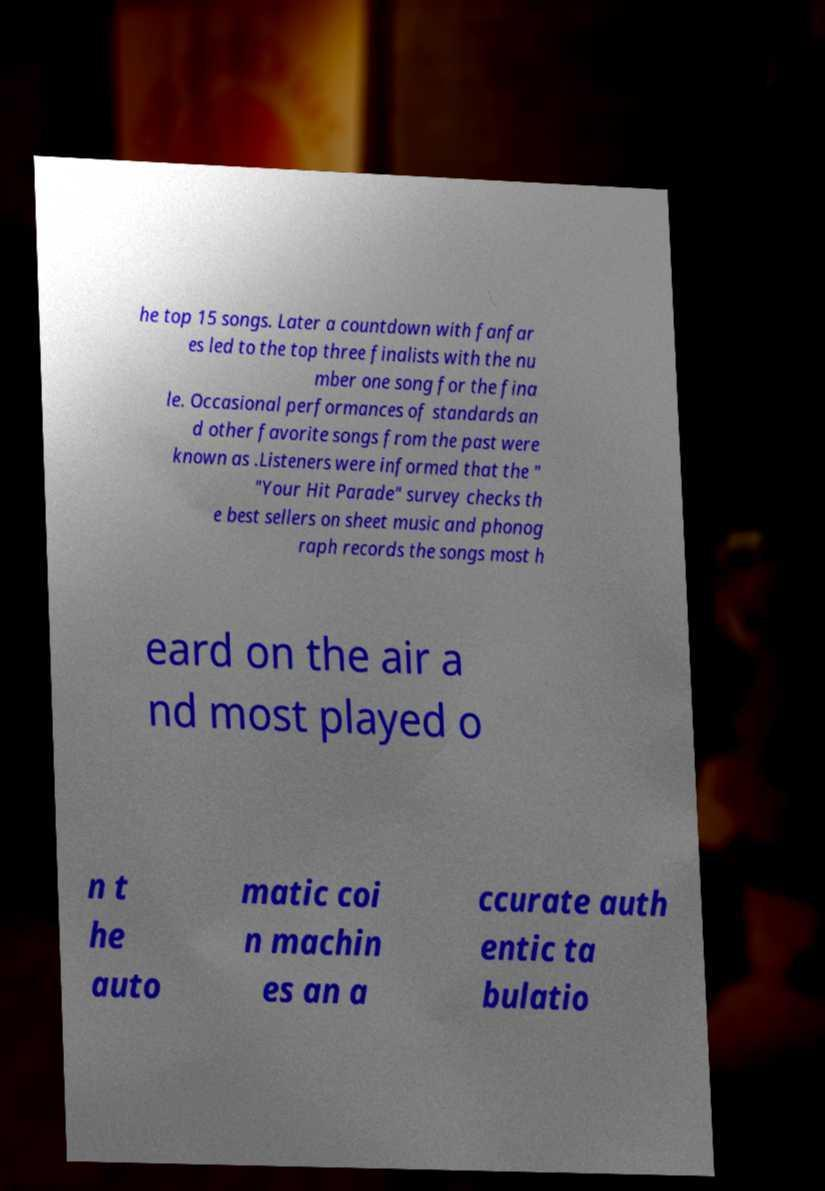I need the written content from this picture converted into text. Can you do that? he top 15 songs. Later a countdown with fanfar es led to the top three finalists with the nu mber one song for the fina le. Occasional performances of standards an d other favorite songs from the past were known as .Listeners were informed that the " "Your Hit Parade" survey checks th e best sellers on sheet music and phonog raph records the songs most h eard on the air a nd most played o n t he auto matic coi n machin es an a ccurate auth entic ta bulatio 